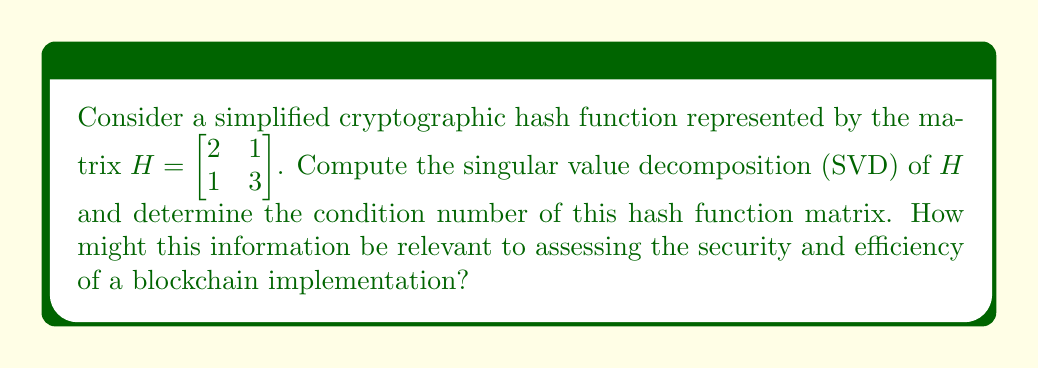What is the answer to this math problem? To compute the singular value decomposition (SVD) of matrix $H$, we follow these steps:

1) First, calculate $H^TH$:
   $$H^TH = \begin{bmatrix} 2 & 1 \\ 1 & 3 \end{bmatrix} \begin{bmatrix} 2 & 1 \\ 1 & 3 \end{bmatrix} = \begin{bmatrix} 5 & 5 \\ 5 & 10 \end{bmatrix}$$

2) Find the eigenvalues of $H^TH$:
   $det(H^TH - \lambda I) = \begin{vmatrix} 5-\lambda & 5 \\ 5 & 10-\lambda \end{vmatrix} = (5-\lambda)(10-\lambda) - 25 = \lambda^2 - 15\lambda + 25 = 0$
   Solving this equation: $\lambda_1 = 12.0711$, $\lambda_2 = 2.9289$

3) The singular values are the square roots of these eigenvalues:
   $\sigma_1 = \sqrt{12.0711} \approx 3.4745$, $\sigma_2 = \sqrt{2.9289} \approx 1.7114$

4) Find the right singular vectors (eigenvectors of $H^TH$):
   For $\lambda_1 = 12.0711$: $v_1 = [0.7071, 0.7071]^T$
   For $\lambda_2 = 2.9289$: $v_2 = [-0.7071, 0.7071]^T$

5) Find the left singular vectors:
   $u_1 = \frac{1}{\sigma_1}Hv_1 \approx [0.5411, 0.8409]^T$
   $u_2 = \frac{1}{\sigma_2}Hv_2 \approx [-0.8409, 0.5411]^T$

6) The SVD of $H$ is:
   $$H = U\Sigma V^T = \begin{bmatrix} 0.5411 & -0.8409 \\ 0.8409 & 0.5411 \end{bmatrix} \begin{bmatrix} 3.4745 & 0 \\ 0 & 1.7114 \end{bmatrix} \begin{bmatrix} 0.7071 & -0.7071 \\ 0.7071 & 0.7071 \end{bmatrix}$$

7) The condition number is the ratio of the largest to smallest singular value:
   $\kappa(H) = \frac{\sigma_1}{\sigma_2} \approx 2.0303$

This information is relevant to blockchain implementation as it provides insights into the stability and sensitivity of the hash function. A low condition number (close to 1) indicates a well-conditioned matrix, suggesting that the hash function is stable and less susceptible to small changes in input. This is crucial for maintaining the integrity and security of the blockchain, as it ensures that similar inputs produce distinctly different hash outputs, reducing the risk of collisions and enhancing the overall robustness of the cryptographic system.
Answer: SVD: $H = U\Sigma V^T$, where $U = \begin{bmatrix} 0.5411 & -0.8409 \\ 0.8409 & 0.5411 \end{bmatrix}$, $\Sigma = \begin{bmatrix} 3.4745 & 0 \\ 0 & 1.7114 \end{bmatrix}$, $V^T = \begin{bmatrix} 0.7071 & -0.7071 \\ 0.7071 & 0.7071 \end{bmatrix}$. Condition number: $\kappa(H) \approx 2.0303$. 